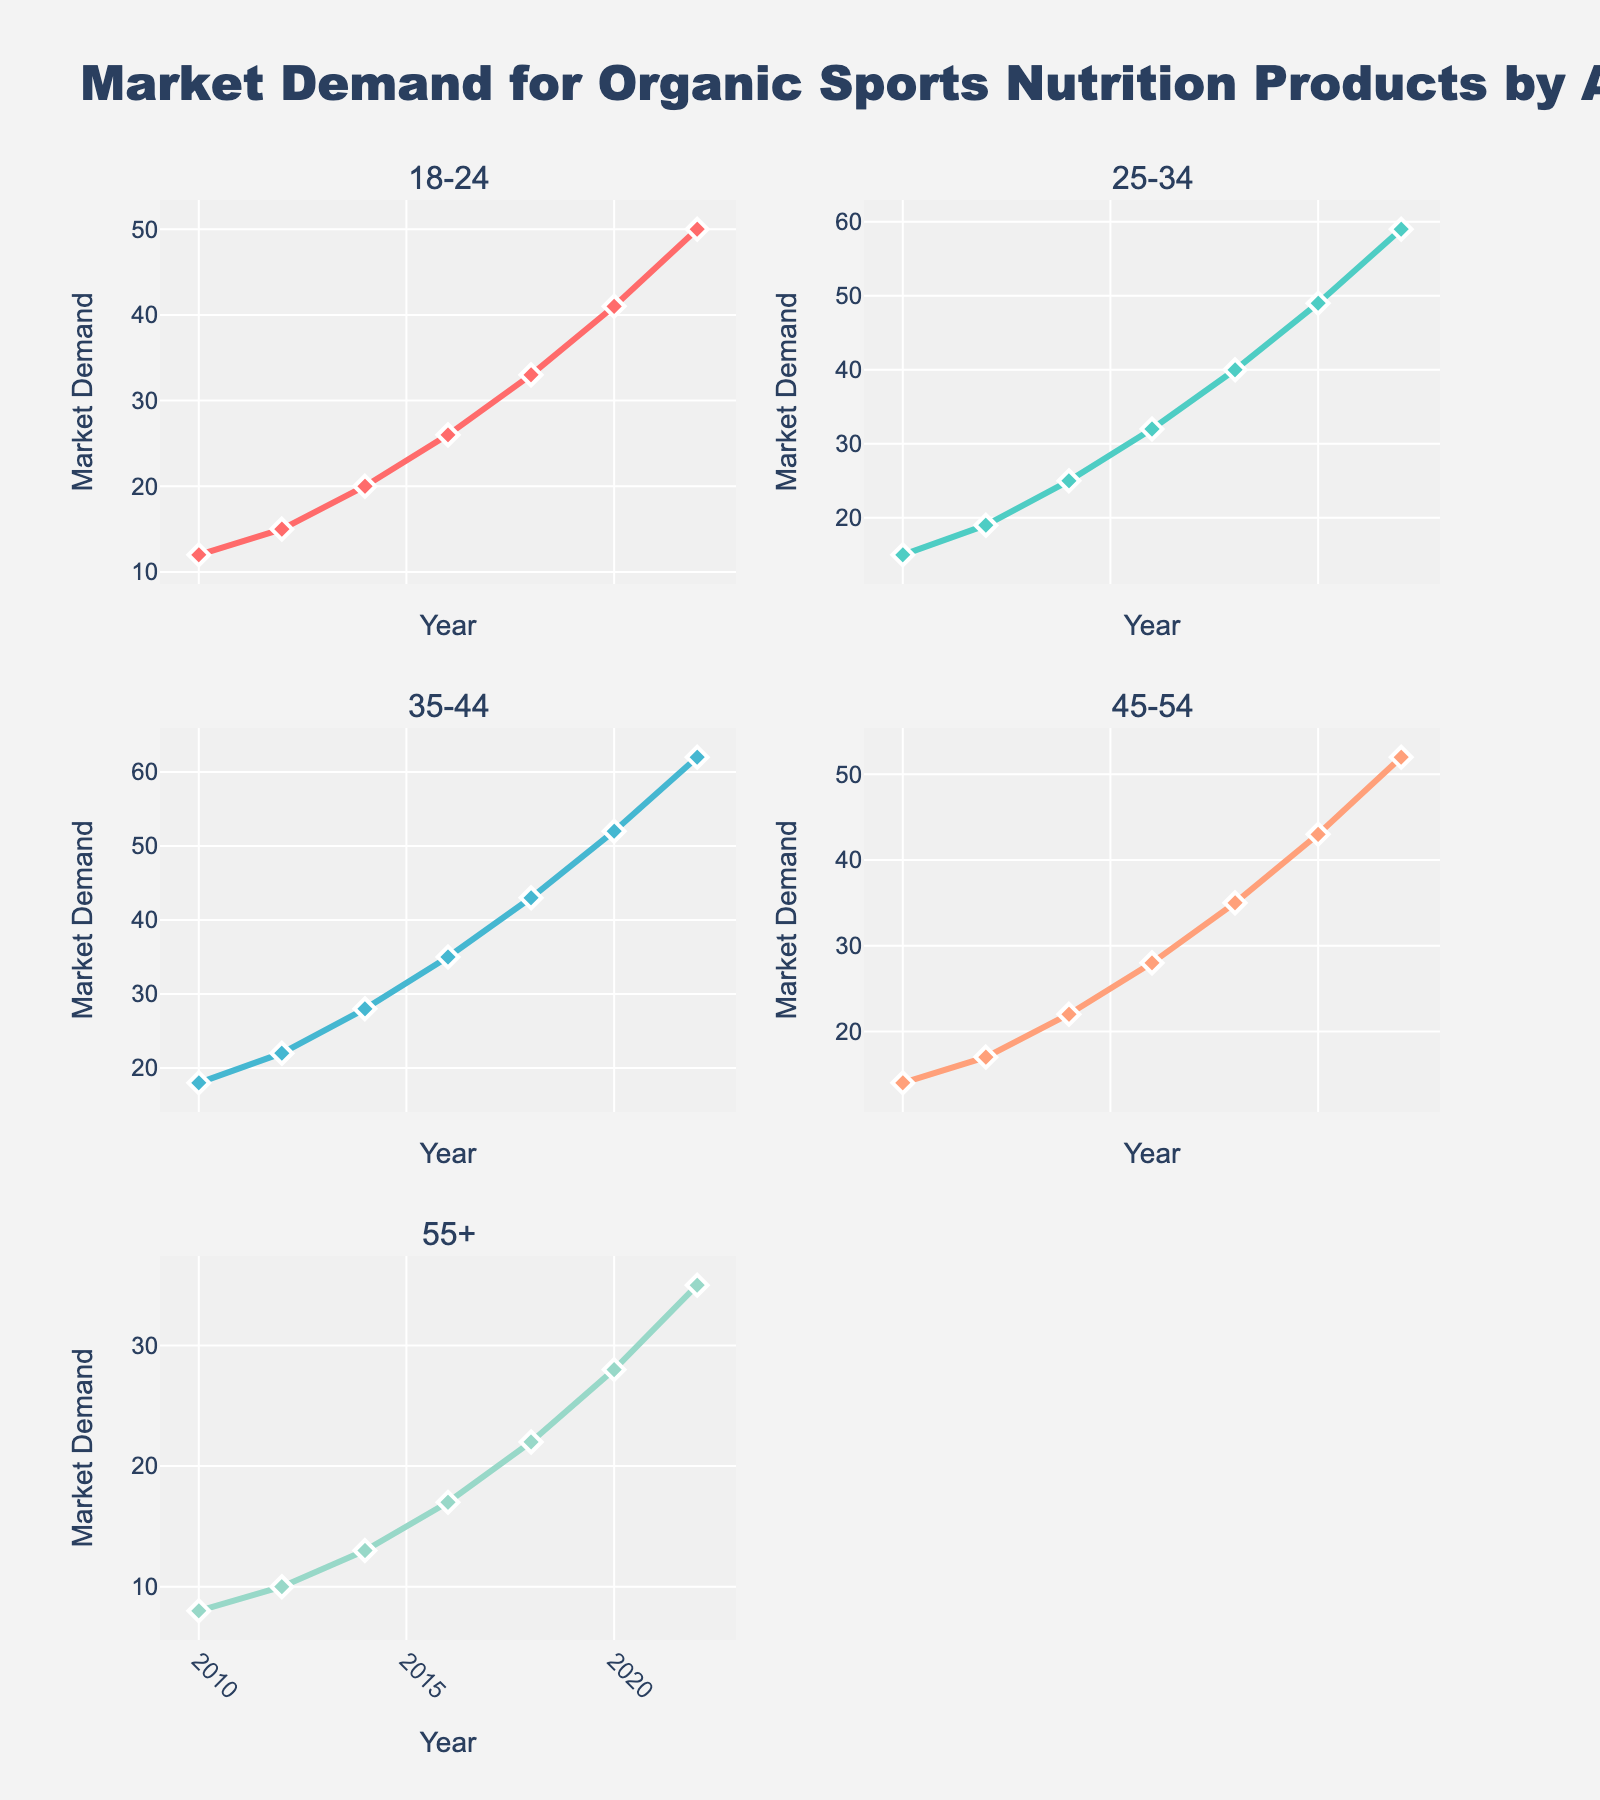Which component has the highest rejection rate in January 2023? In January 2023, the rejection rates for different components are displayed on the y-axes of their respective subplots. The component with the highest value can be identified by comparing the y-values. Glass Fiber Core has a rejection rate of 1.2%, which is the highest.
Answer: Glass Fiber Core How does the rejection rate of Cladding change from February to March 2023? To determine the change in rejection rate of Cladding, observe the Cladding subplot's y-values for February and March. In February, the rate is 0.9%, and in March, it is 1.1%. The rate increases by 0.2%.
Answer: Increases by 0.2% What is the average rejection rate for Buffer Coating in the first quarter (Jan-Mar) of 2023? To find the average, sum the rejection rates for Buffer Coating from January, February, and March, then divide by 3. The rates are 1.5%, 1.3%, and 1.4%, respectively. Sum = 1.5 + 1.3 + 1.4 = 4.2. Average = 4.2/3 = 1.4%.
Answer: 1.4% Which month shows the lowest rejection rate for the Strength Member? Inspect the Strength Member subplot and compare the y-values across all months. The lowest rejection rate appears in May and November 2023 at 0.3%.
Answer: May and November Between Glass Fiber Core and Outer Jacket, which component shows a higher rejection rate in October 2023? Compare the rejection rates for Glass Fiber Core and Outer Jacket in October 2023 by looking at their respective subplots. The rates are 1.2% for Glass Fiber Core and 0.3% for Outer Jacket. Glass Fiber Core is higher.
Answer: Glass Fiber Core Is there any month when all components have the same rejection rate? By scanning through all subplots, one can verify that no month shows identical rejection rates for all components. Each month displays variations in values among the different components.
Answer: No How does the rejection rate trend for Outer Jacket change over the year 2023? Review the Outer Jacket subplot for trends over the months. The rejection rate starts at 0.3% in January and, although it fluctuates, generally remains between 0.2% and 0.4% throughout the year with no distinct upward or downward trend.
Answer: Remains stable Are there more instances of rejection rates decreasing or increasing for Cladding over the months? Observe the Cladding subplot and track changes from month to month. The rate decreases from January to April, increases from April to June, decreases from June to August, and increases again from August to September. There are 6 months with decreasing rates and 6 with increasing rates, showing an equal number of instances.
Answer: Equal instances In which months do both Glass Fiber Core and Strength Member have their highest rejection rates? Find the peak rejection rates for both components by looking at their subplots. Both have their highest rates in January for Glass Fiber Core (1.2%) and February for Strength Member (0.6%).
Answer: January for Glass Fiber Core, February for Strength Member What is the rejection rate difference between Cladding and Buffer Coating in December 2023? Check the rejection rates on their respective subplots for December. Cladding has a rate of 1.0%, and Buffer Coating has a rate of 1.2%. The difference is 1.2% - 1.0% = 0.2%.
Answer: 0.2% 